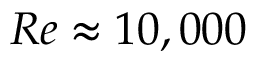<formula> <loc_0><loc_0><loc_500><loc_500>R e \approx 1 0 , 0 0 0</formula> 